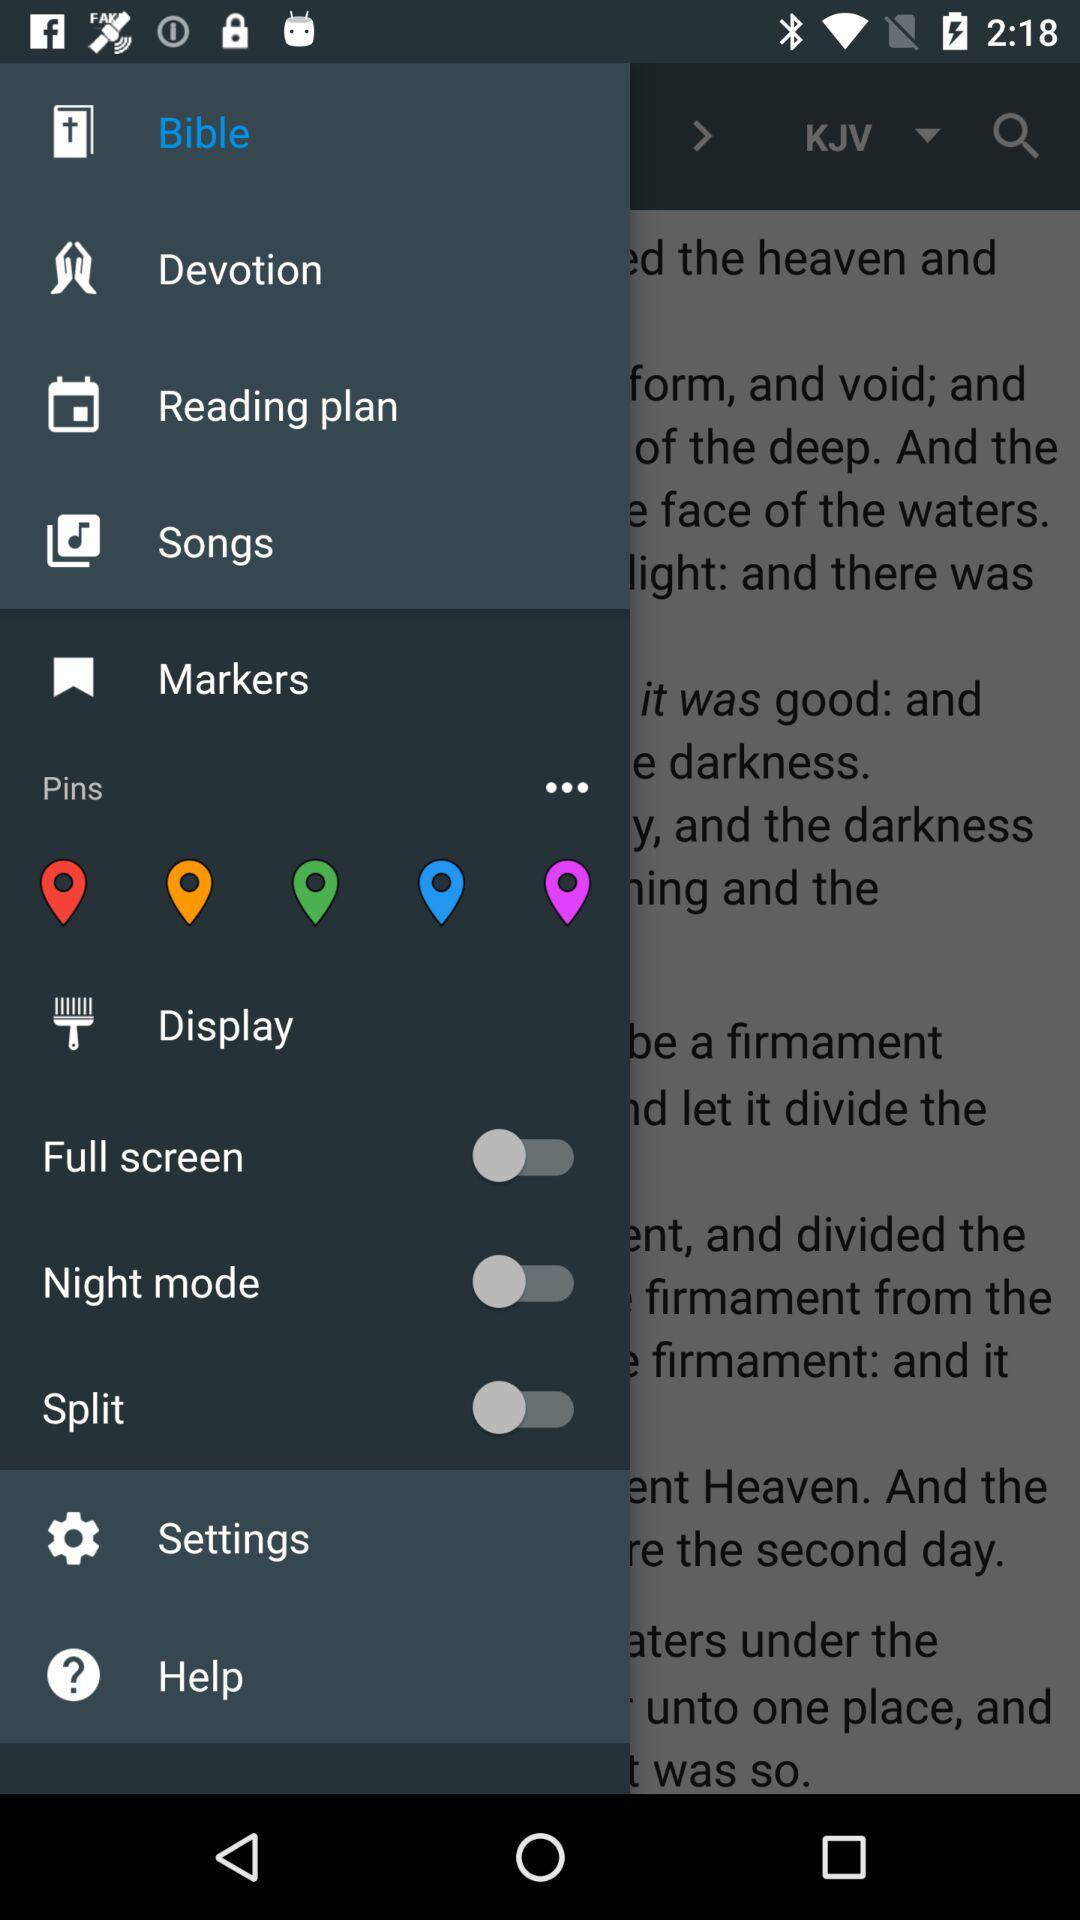What's the status of "Full screen"? The status of "Full screen" is "off". 